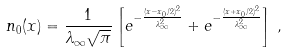Convert formula to latex. <formula><loc_0><loc_0><loc_500><loc_500>n _ { 0 } ( x ) = \frac { 1 } { \lambda _ { \infty } \sqrt { \pi } } \left [ e ^ { - \frac { ( x - x _ { 0 } / 2 ) ^ { 2 } } { \lambda _ { \infty } ^ { 2 } } } + e ^ { - \frac { ( x + x _ { 0 } / 2 ) ^ { 2 } } { \lambda _ { \infty } ^ { 2 } } } \right ] \, ,</formula> 